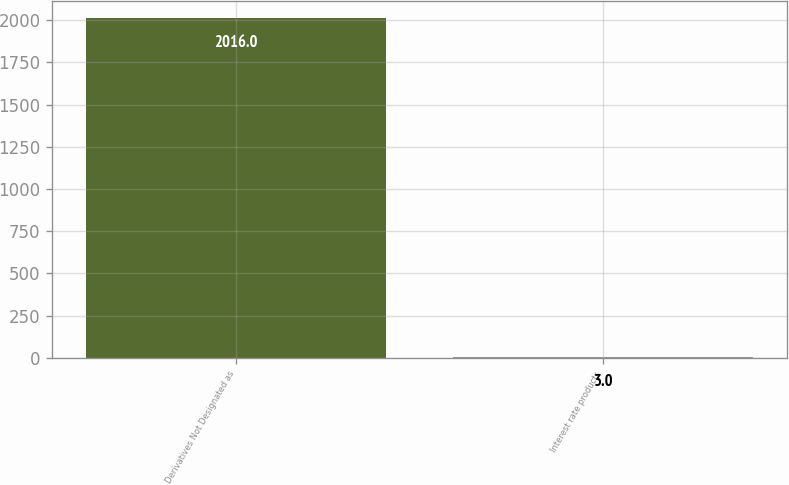Convert chart to OTSL. <chart><loc_0><loc_0><loc_500><loc_500><bar_chart><fcel>Derivatives Not Designated as<fcel>Interest rate products<nl><fcel>2016<fcel>3<nl></chart> 